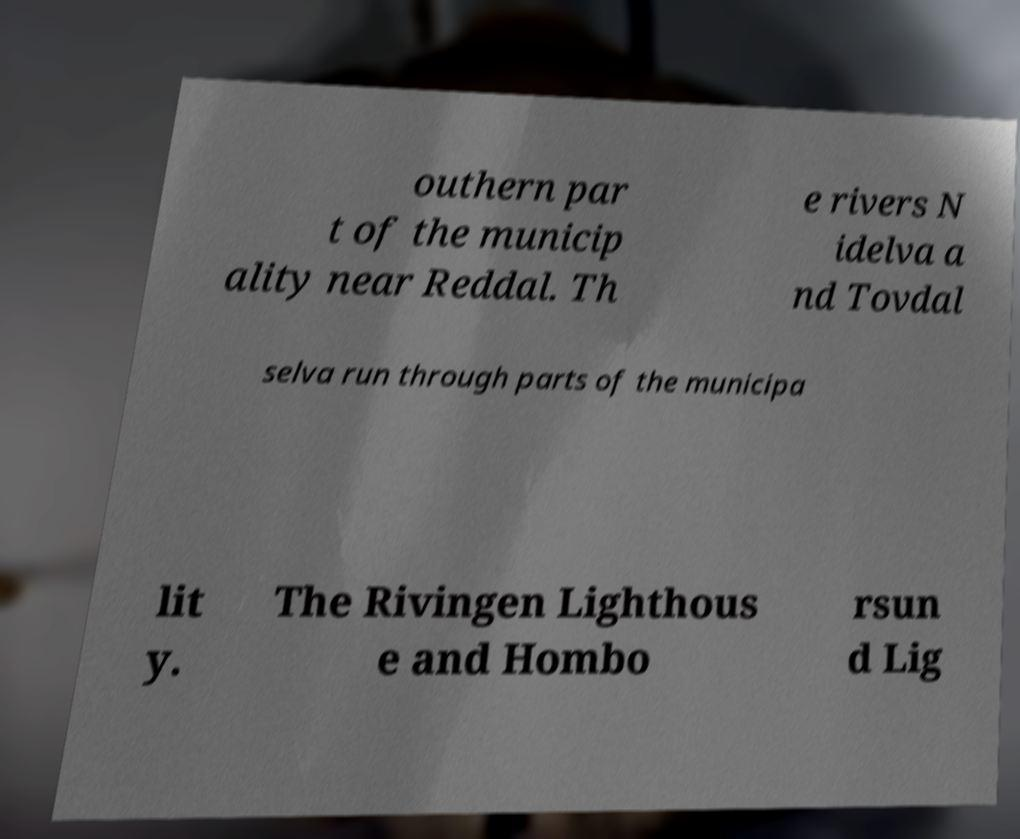Please identify and transcribe the text found in this image. outhern par t of the municip ality near Reddal. Th e rivers N idelva a nd Tovdal selva run through parts of the municipa lit y. The Rivingen Lighthous e and Hombo rsun d Lig 